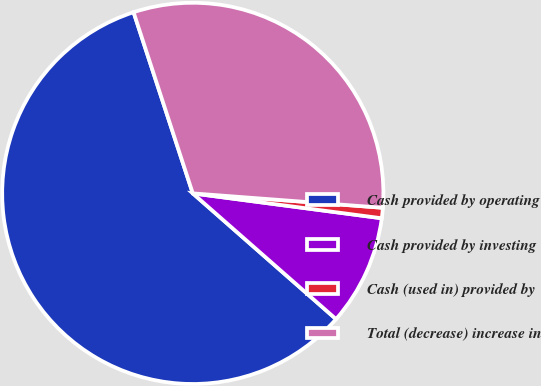Convert chart. <chart><loc_0><loc_0><loc_500><loc_500><pie_chart><fcel>Cash provided by operating<fcel>Cash provided by investing<fcel>Cash (used in) provided by<fcel>Total (decrease) increase in<nl><fcel>58.5%<fcel>9.38%<fcel>0.88%<fcel>31.23%<nl></chart> 